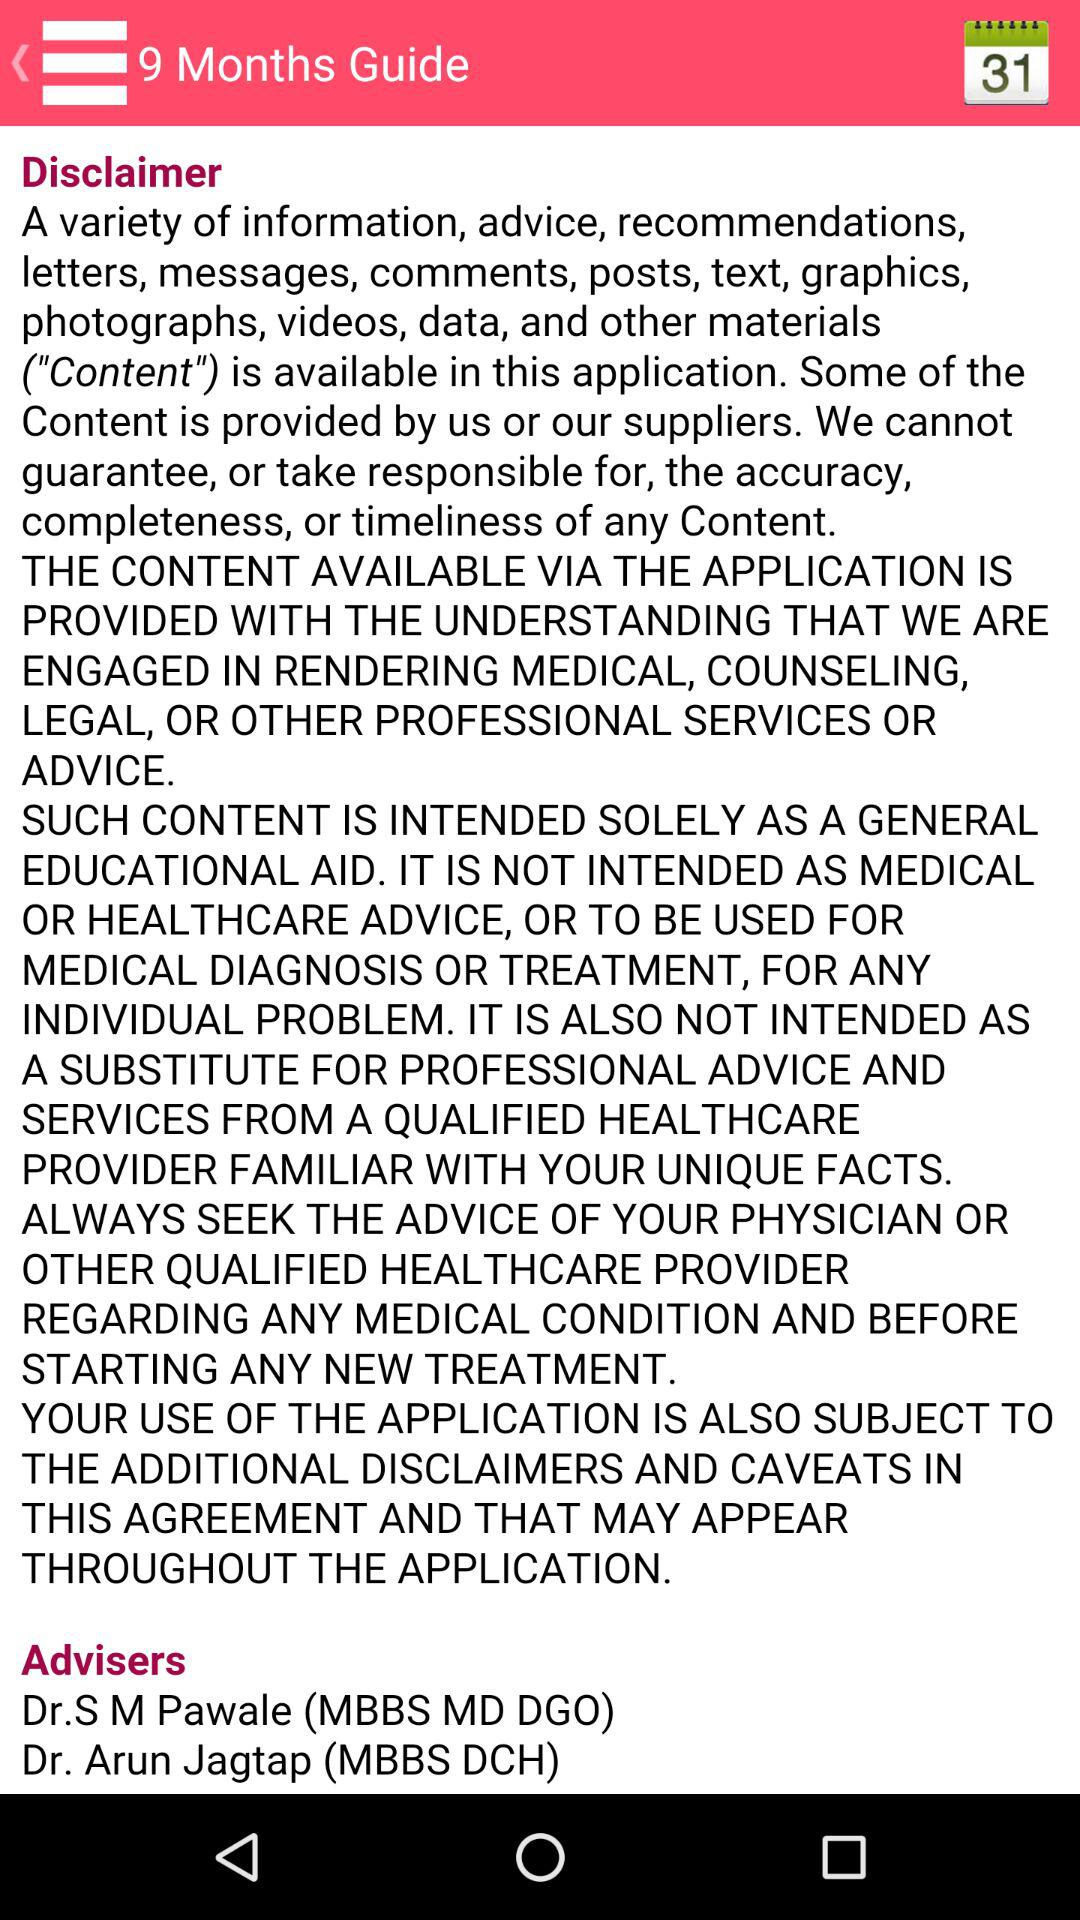How many advisers are there?
Answer the question using a single word or phrase. 2 